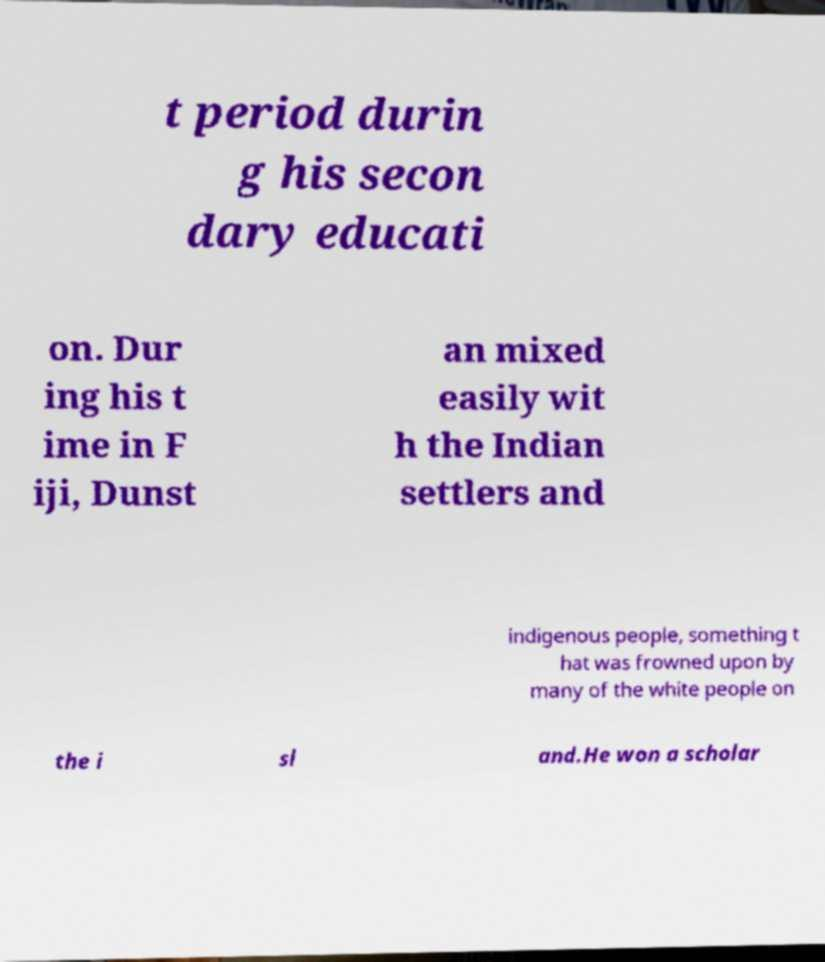I need the written content from this picture converted into text. Can you do that? t period durin g his secon dary educati on. Dur ing his t ime in F iji, Dunst an mixed easily wit h the Indian settlers and indigenous people, something t hat was frowned upon by many of the white people on the i sl and.He won a scholar 